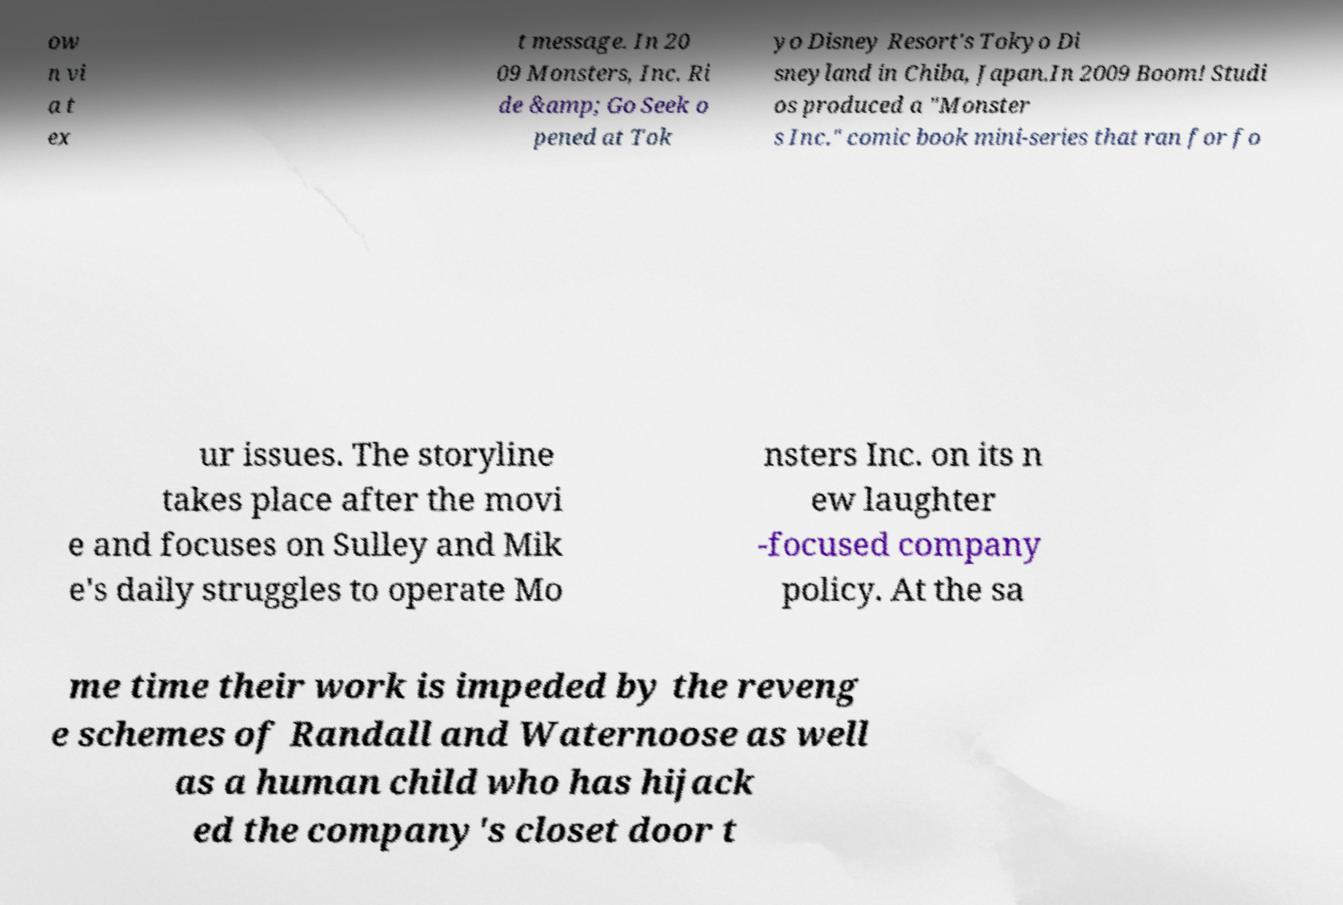Can you read and provide the text displayed in the image?This photo seems to have some interesting text. Can you extract and type it out for me? ow n vi a t ex t message. In 20 09 Monsters, Inc. Ri de &amp; Go Seek o pened at Tok yo Disney Resort's Tokyo Di sneyland in Chiba, Japan.In 2009 Boom! Studi os produced a "Monster s Inc." comic book mini-series that ran for fo ur issues. The storyline takes place after the movi e and focuses on Sulley and Mik e's daily struggles to operate Mo nsters Inc. on its n ew laughter -focused company policy. At the sa me time their work is impeded by the reveng e schemes of Randall and Waternoose as well as a human child who has hijack ed the company's closet door t 